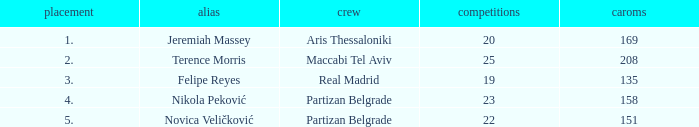What is the number of Games for the Maccabi Tel Aviv Team with less than 208 Rebounds? None. 